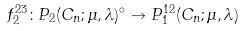Convert formula to latex. <formula><loc_0><loc_0><loc_500><loc_500>f ^ { 2 3 } _ { 2 } \colon P _ { 2 } ( C _ { n } ; \mu , \lambda ) ^ { \circ } \to P ^ { 1 2 } _ { 1 } ( C _ { n } ; \mu , \lambda )</formula> 